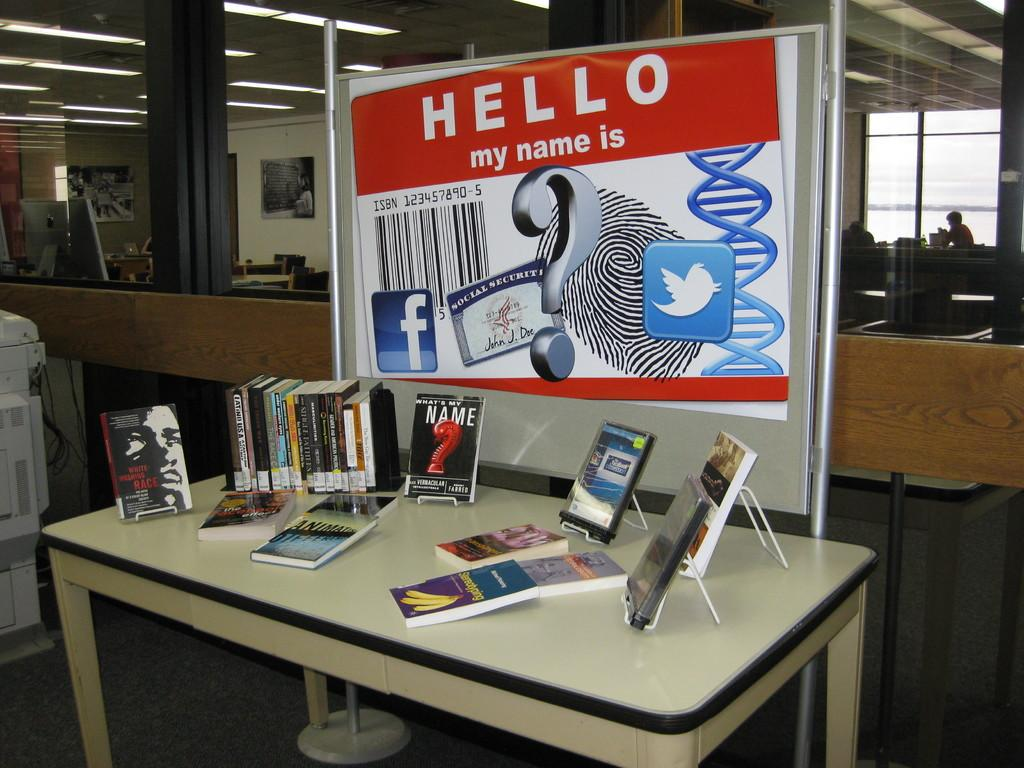<image>
Provide a brief description of the given image. A big poster says "Hello my name is" with a big barcode on it above a desk of books. 